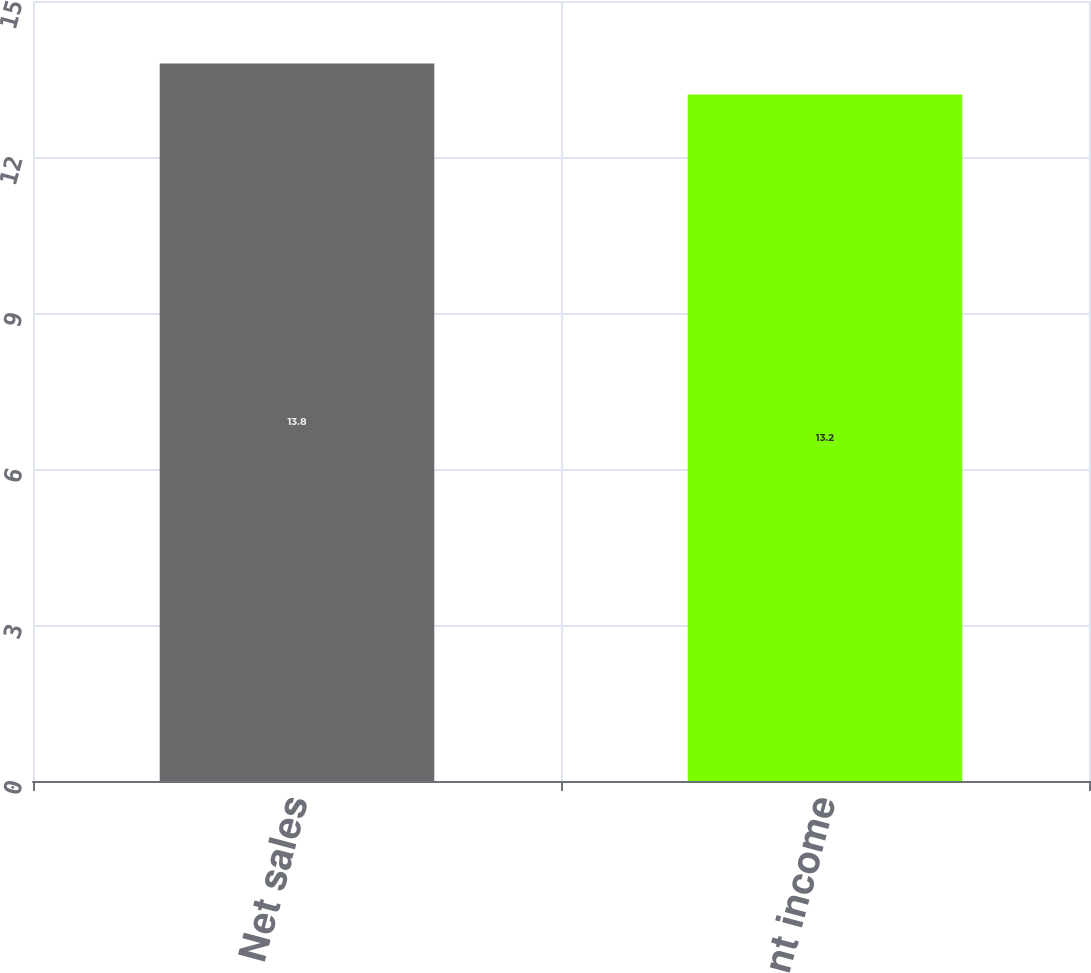<chart> <loc_0><loc_0><loc_500><loc_500><bar_chart><fcel>Net sales<fcel>Segment income<nl><fcel>13.8<fcel>13.2<nl></chart> 